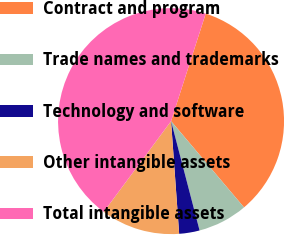<chart> <loc_0><loc_0><loc_500><loc_500><pie_chart><fcel>Contract and program<fcel>Trade names and trademarks<fcel>Technology and software<fcel>Other intangible assets<fcel>Total intangible assets<nl><fcel>33.86%<fcel>7.11%<fcel>2.92%<fcel>11.3%<fcel>44.8%<nl></chart> 